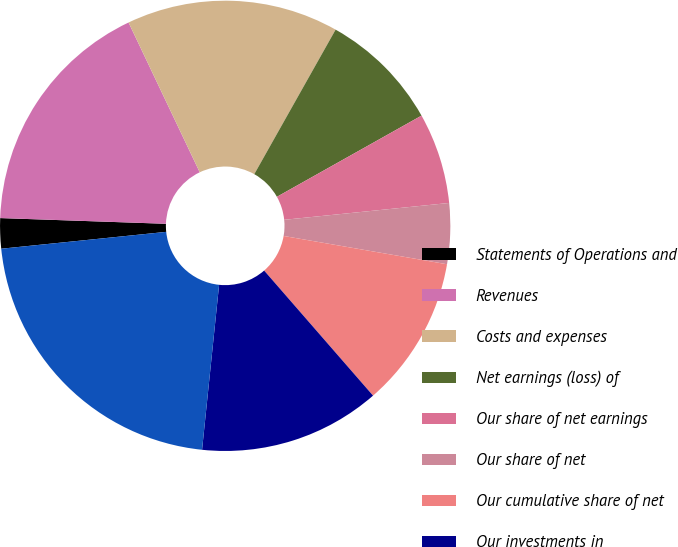Convert chart. <chart><loc_0><loc_0><loc_500><loc_500><pie_chart><fcel>Statements of Operations and<fcel>Revenues<fcel>Costs and expenses<fcel>Net earnings (loss) of<fcel>Our share of net earnings<fcel>Our share of net<fcel>Our cumulative share of net<fcel>Our investments in<fcel>Equity of the unconsolidated<fcel>Our investment in the<nl><fcel>2.17%<fcel>17.39%<fcel>15.22%<fcel>8.7%<fcel>6.52%<fcel>4.35%<fcel>10.87%<fcel>13.04%<fcel>21.74%<fcel>0.0%<nl></chart> 